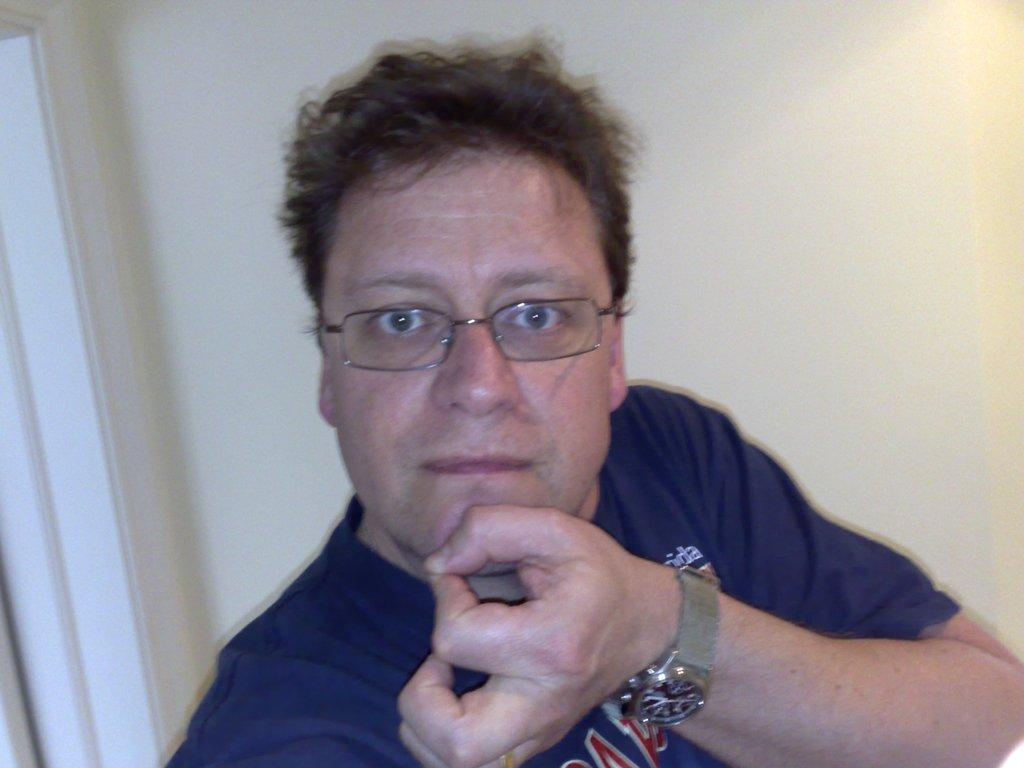Who is present in the image? There is a man in the image. What can be seen in the background of the image? There is a wall in the background of the image. What type of beetle can be seen participating in the competition in the image? There is no beetle or competition present in the image; it features a man and a wall in the background. 